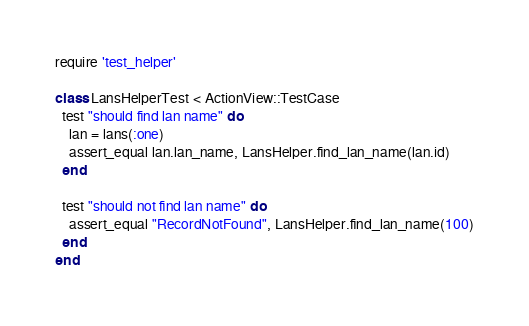<code> <loc_0><loc_0><loc_500><loc_500><_Ruby_>require 'test_helper'

class LansHelperTest < ActionView::TestCase
  test "should find lan name" do
    lan = lans(:one)
    assert_equal lan.lan_name, LansHelper.find_lan_name(lan.id)
  end

  test "should not find lan name" do
    assert_equal "RecordNotFound", LansHelper.find_lan_name(100)
  end
end
</code> 